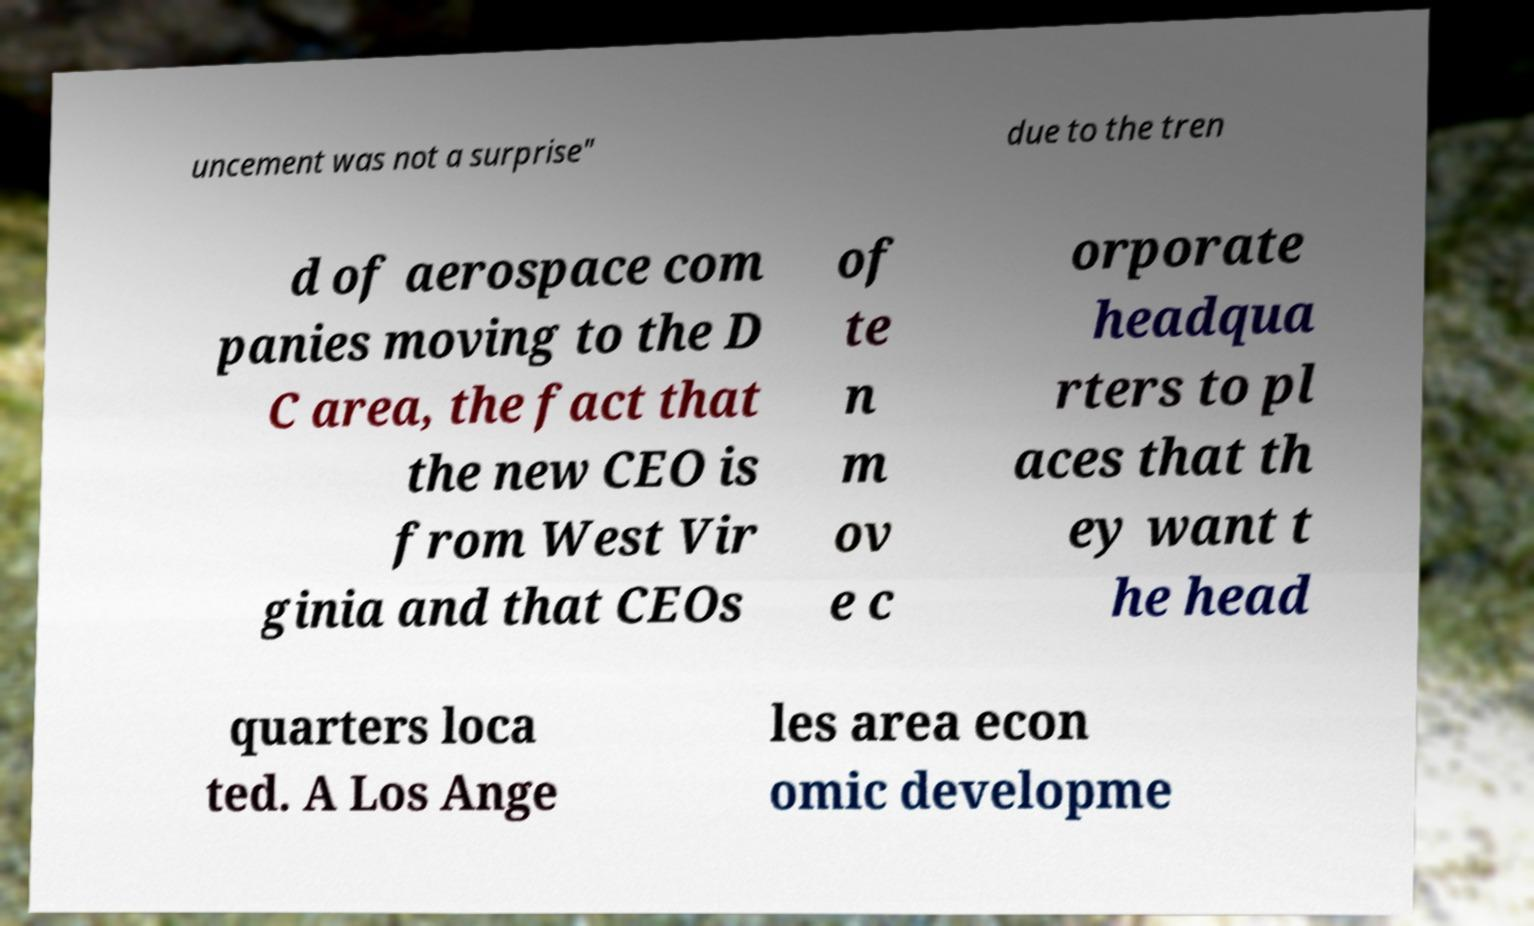Please read and relay the text visible in this image. What does it say? uncement was not a surprise" due to the tren d of aerospace com panies moving to the D C area, the fact that the new CEO is from West Vir ginia and that CEOs of te n m ov e c orporate headqua rters to pl aces that th ey want t he head quarters loca ted. A Los Ange les area econ omic developme 